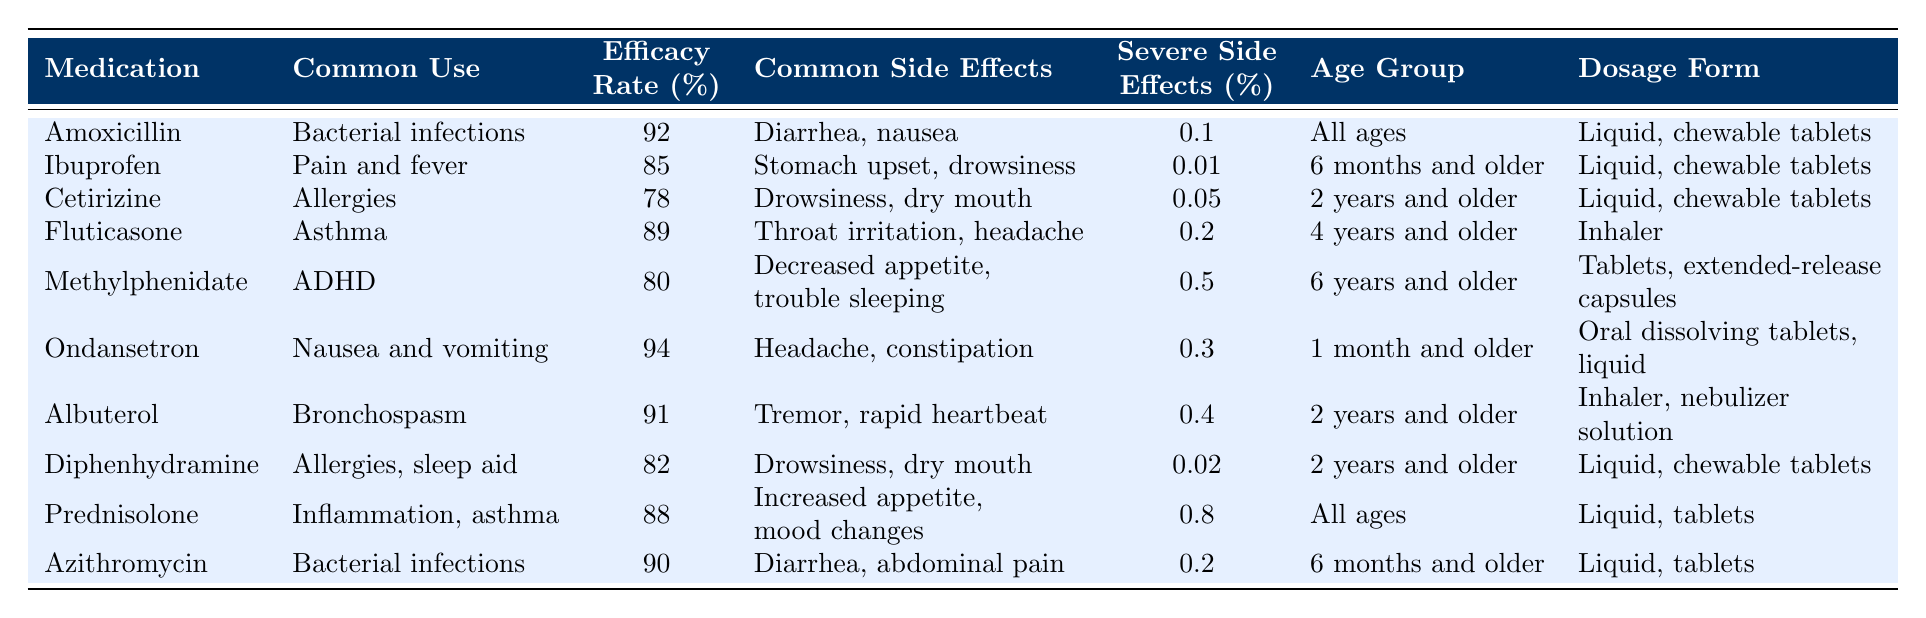What is the efficacy rate of Amoxicillin? The efficacy rate for Amoxicillin is directly listed in the table under the "Efficacy Rate (%)" column, which shows a value of 92%.
Answer: 92% Which medication has the highest efficacy rate? Reviewing the "Efficacy Rate (%)" column, Ondansetron has the highest efficacy rate at 94%, which is greater than the efficacy rates of all other medications listed.
Answer: 94% What are the common side effects of Cetirizine? The common side effects are specified in the "Common Side Effects" column for Cetirizine, which lists drowsiness and dry mouth.
Answer: Drowsiness, dry mouth How many medications have a severe side effect percentage greater than 0.2%? Looking at the "Severe Side Effects (%)" column, there are three medications with a percentage greater than 0.2%: Methylphenidate (0.5%), Prednisolone (0.8%), and Albuterol (0.4%). Thus, the count is three.
Answer: 3 Is Fluticasone used for children under 4 years of age? Checking the "Age Group" column for Fluticasone indicates it is for ages "4 years and older," which means it is not recommended for children under that age.
Answer: No What is the most common form of dosage for the medications listed? The "Dosage Form" column shows that both liquid and chewable tablets are commonly used forms for several medications; however, liquid forms are common for the majority, totaling six medications.
Answer: Liquid, chewable tablets Which medication treats asthma and what are its common side effects? By locating "Asthma" under the "Common Use" column, we find Fluticasone is the relevant medication, with common side effects of throat irritation and headache as listed in the corresponding column.
Answer: Fluticasone; throat irritation, headache Calculate the average efficacy rate of medications treating bacterial infections. The relevant medications are Amoxicillin (92%), Azithromycin (90%), and we find the average by adding these rates (92 + 90) = 182, and then dividing by 2, resulting in 91%.
Answer: 91% What severe side effects does Prednisolone have, and what's their percentage? Checking the respective columns, the side effects for Prednisolone are increased appetite and mood changes, and the percentage of severe side effects is 0.8%.
Answer: Increased appetite, mood changes; 0.8% Is it safe for a 1-month-old to take Ondansetron? The "Age Group" column indicates that Ondansetron can be used for those aged 1 month and older, making it safe for a 1-month-old child.
Answer: Yes 